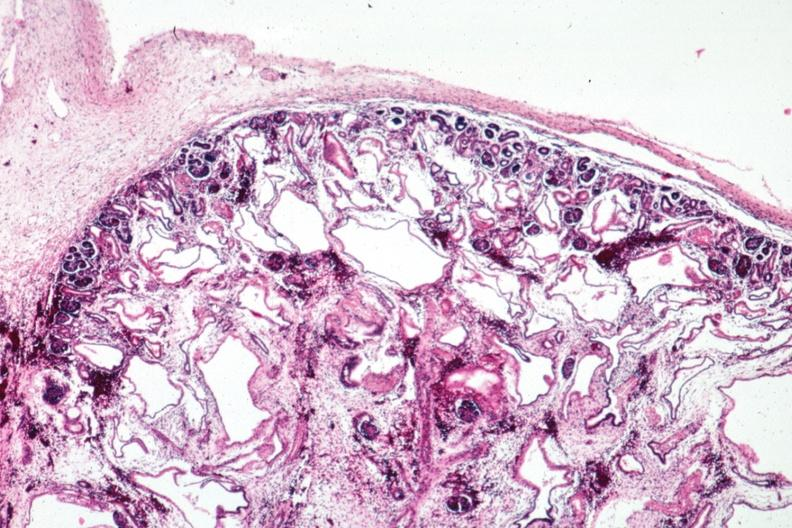where is this?
Answer the question using a single word or phrase. Urinary 